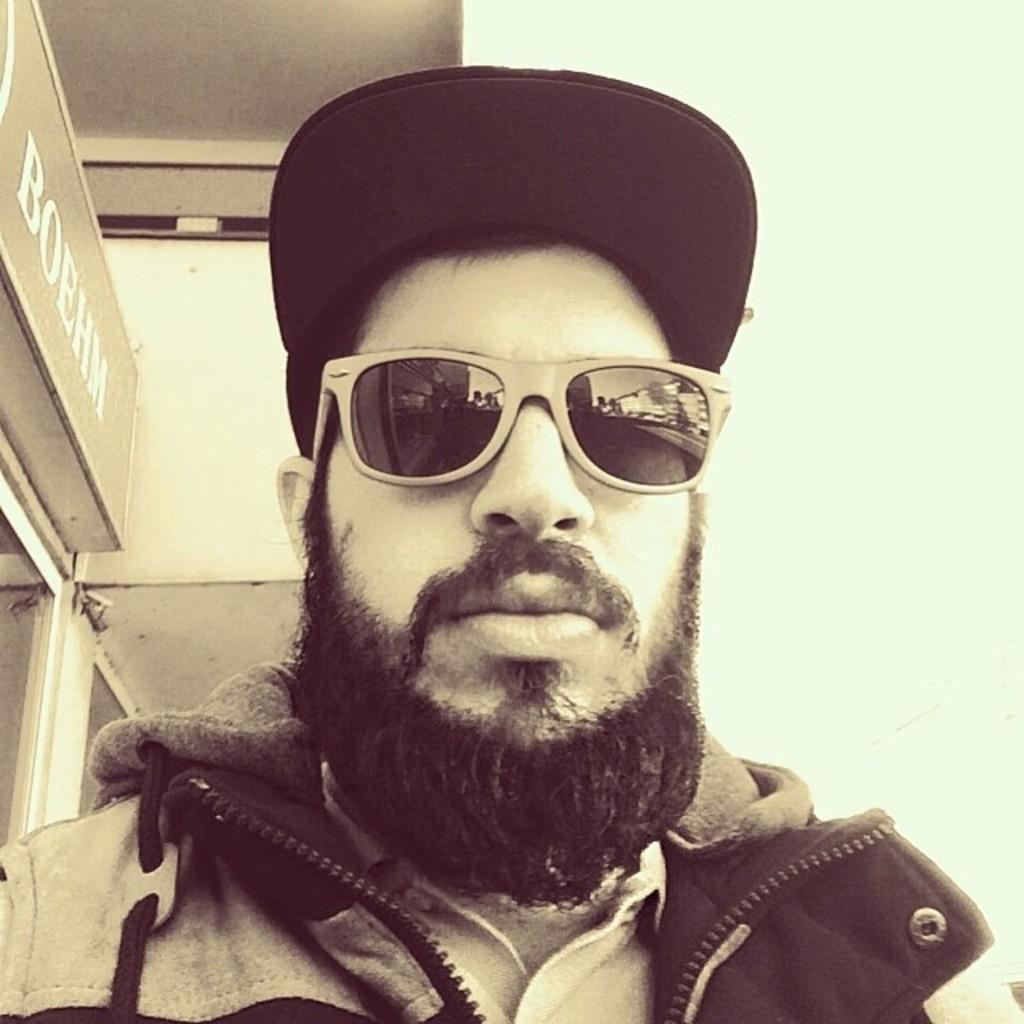What can be seen in the background of the image? There is a wall in the background of the image. What is located on the left side of the image? There is a board on the left side of the image. Who is present in the image? There is a man in the image. What is the man wearing on his head? The man is wearing a cap. What is the man wearing on his upper body? The man is wearing a jacket. What is the man wearing to protect his eyes? The man is wearing goggles. How many cherries are on the board in the image? There are no cherries present in the image; the board is not mentioned to have any cherries on it. What type of bun is the man holding in the image? There is no bun present in the image; the man is not holding any bun. 